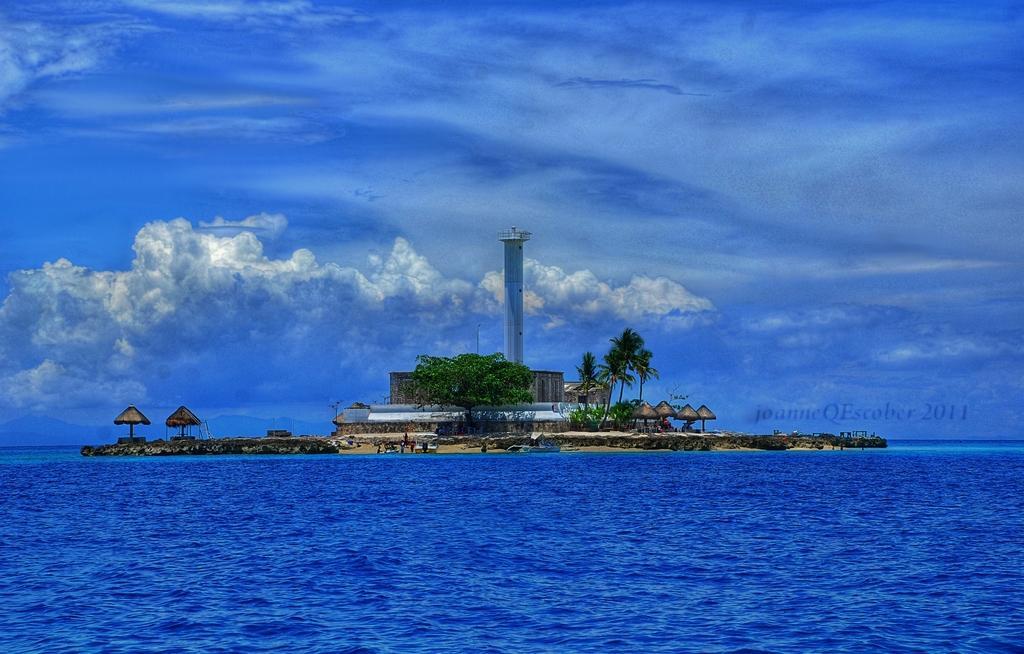How would you summarize this image in a sentence or two? In this image we can see a house, there are huts, trees, a tower, also we can see the ocean, and the cloudy sky, there are text on the image. 